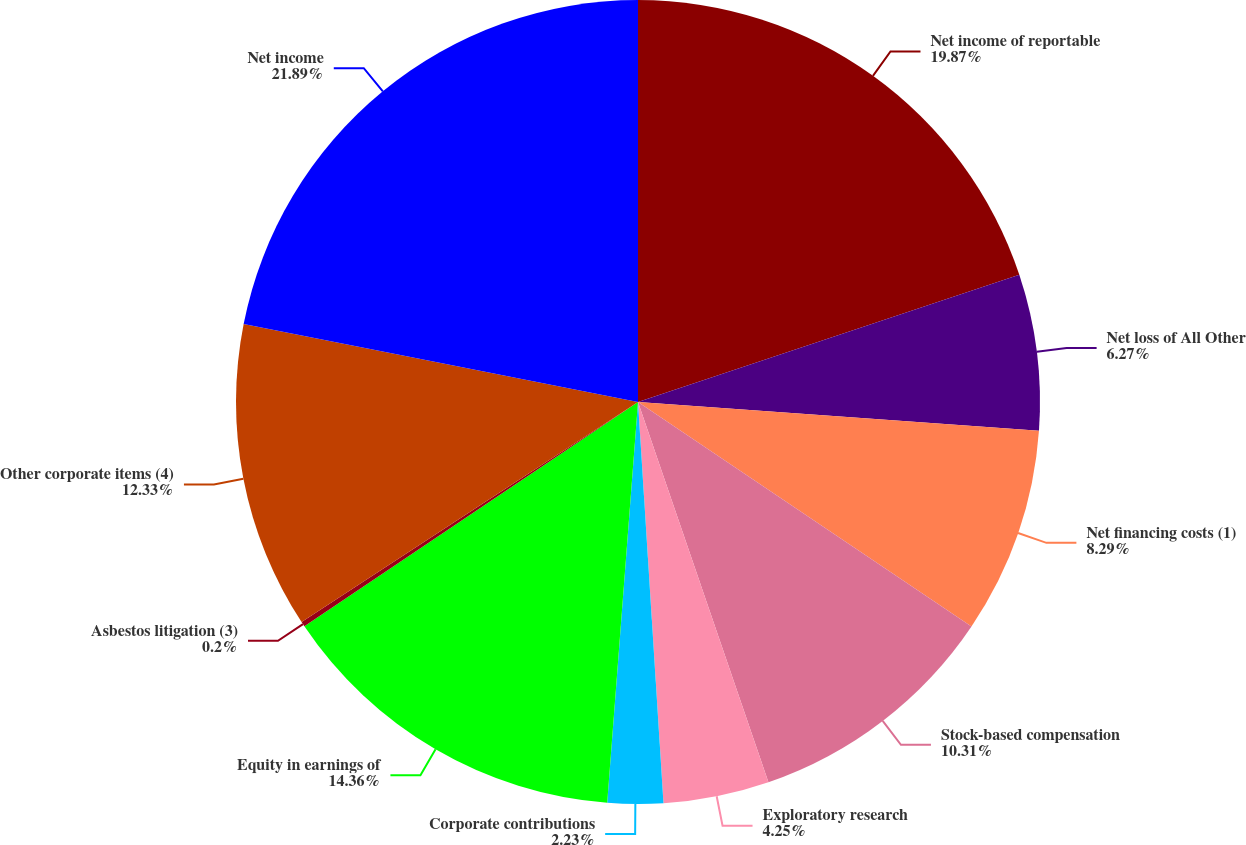Convert chart to OTSL. <chart><loc_0><loc_0><loc_500><loc_500><pie_chart><fcel>Net income of reportable<fcel>Net loss of All Other<fcel>Net financing costs (1)<fcel>Stock-based compensation<fcel>Exploratory research<fcel>Corporate contributions<fcel>Equity in earnings of<fcel>Asbestos litigation (3)<fcel>Other corporate items (4)<fcel>Net income<nl><fcel>19.87%<fcel>6.27%<fcel>8.29%<fcel>10.31%<fcel>4.25%<fcel>2.23%<fcel>14.36%<fcel>0.2%<fcel>12.33%<fcel>21.89%<nl></chart> 